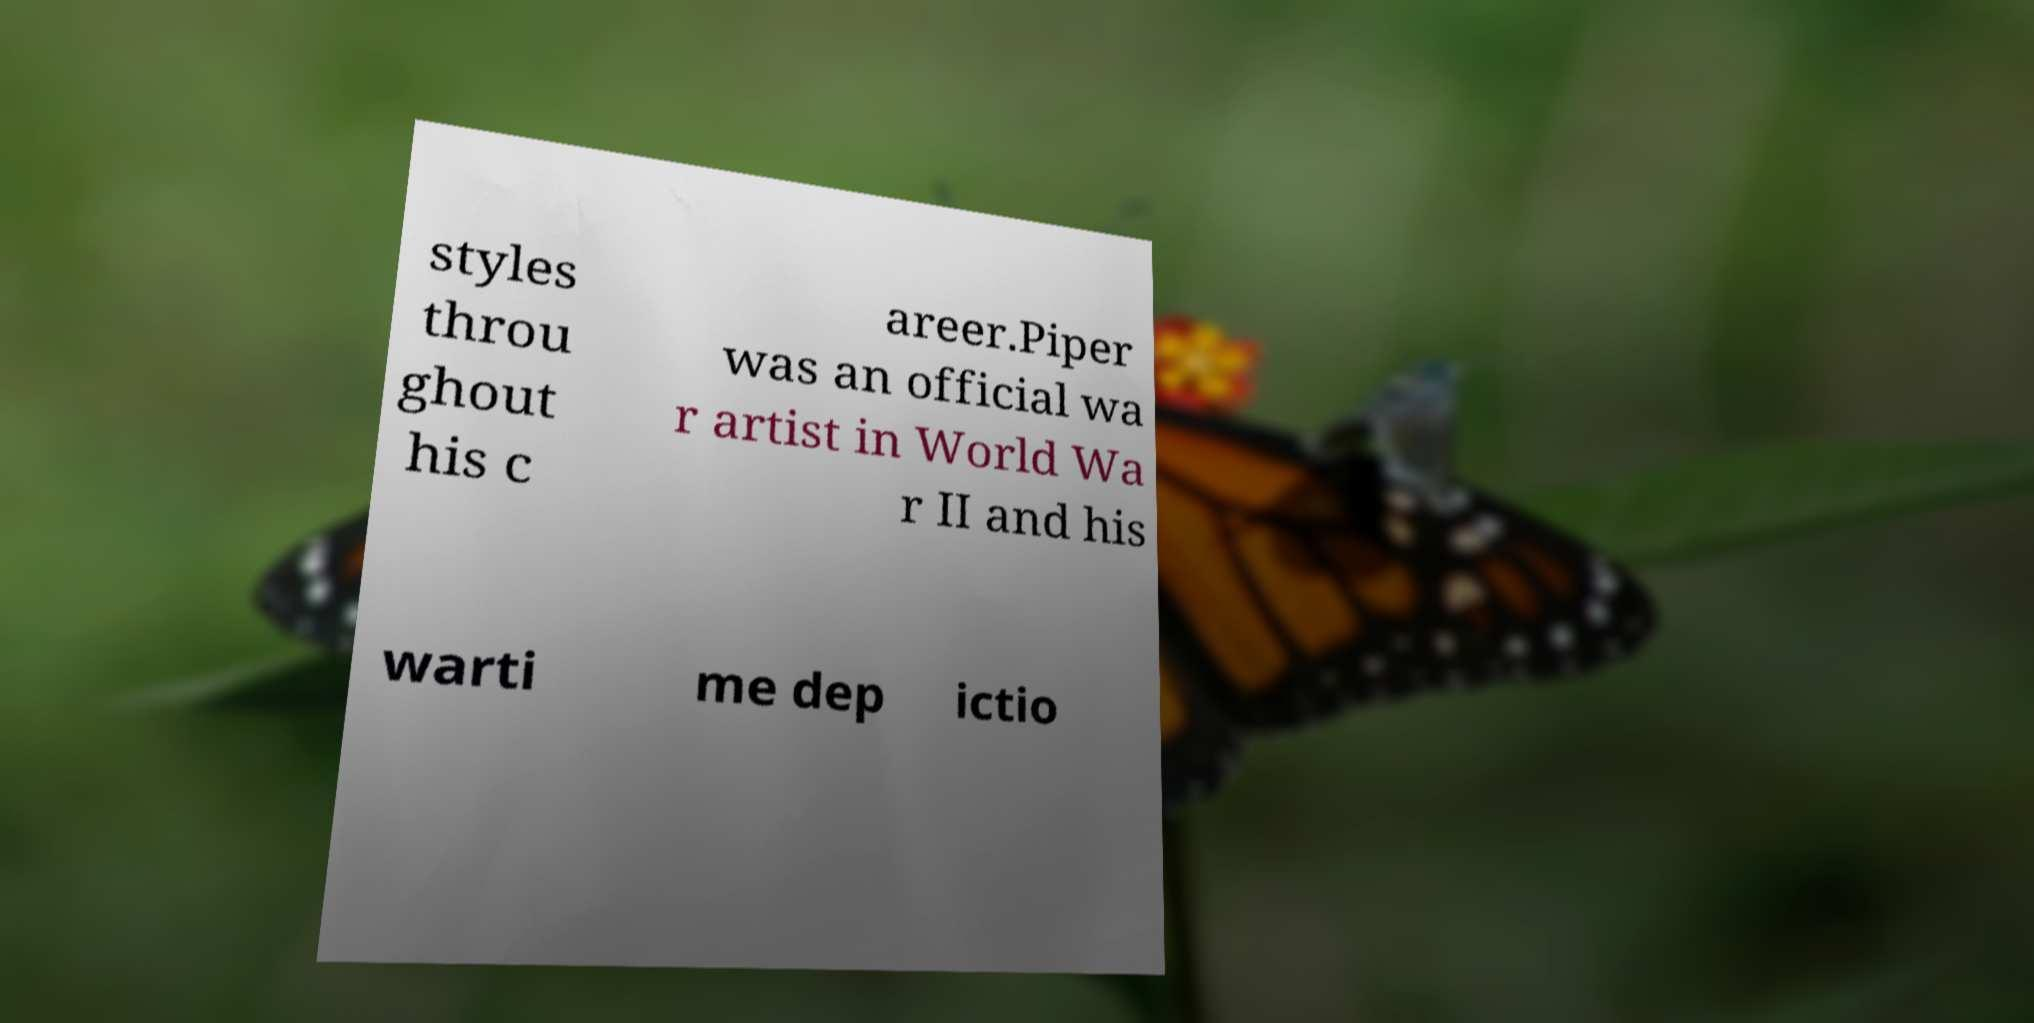There's text embedded in this image that I need extracted. Can you transcribe it verbatim? styles throu ghout his c areer.Piper was an official wa r artist in World Wa r II and his warti me dep ictio 